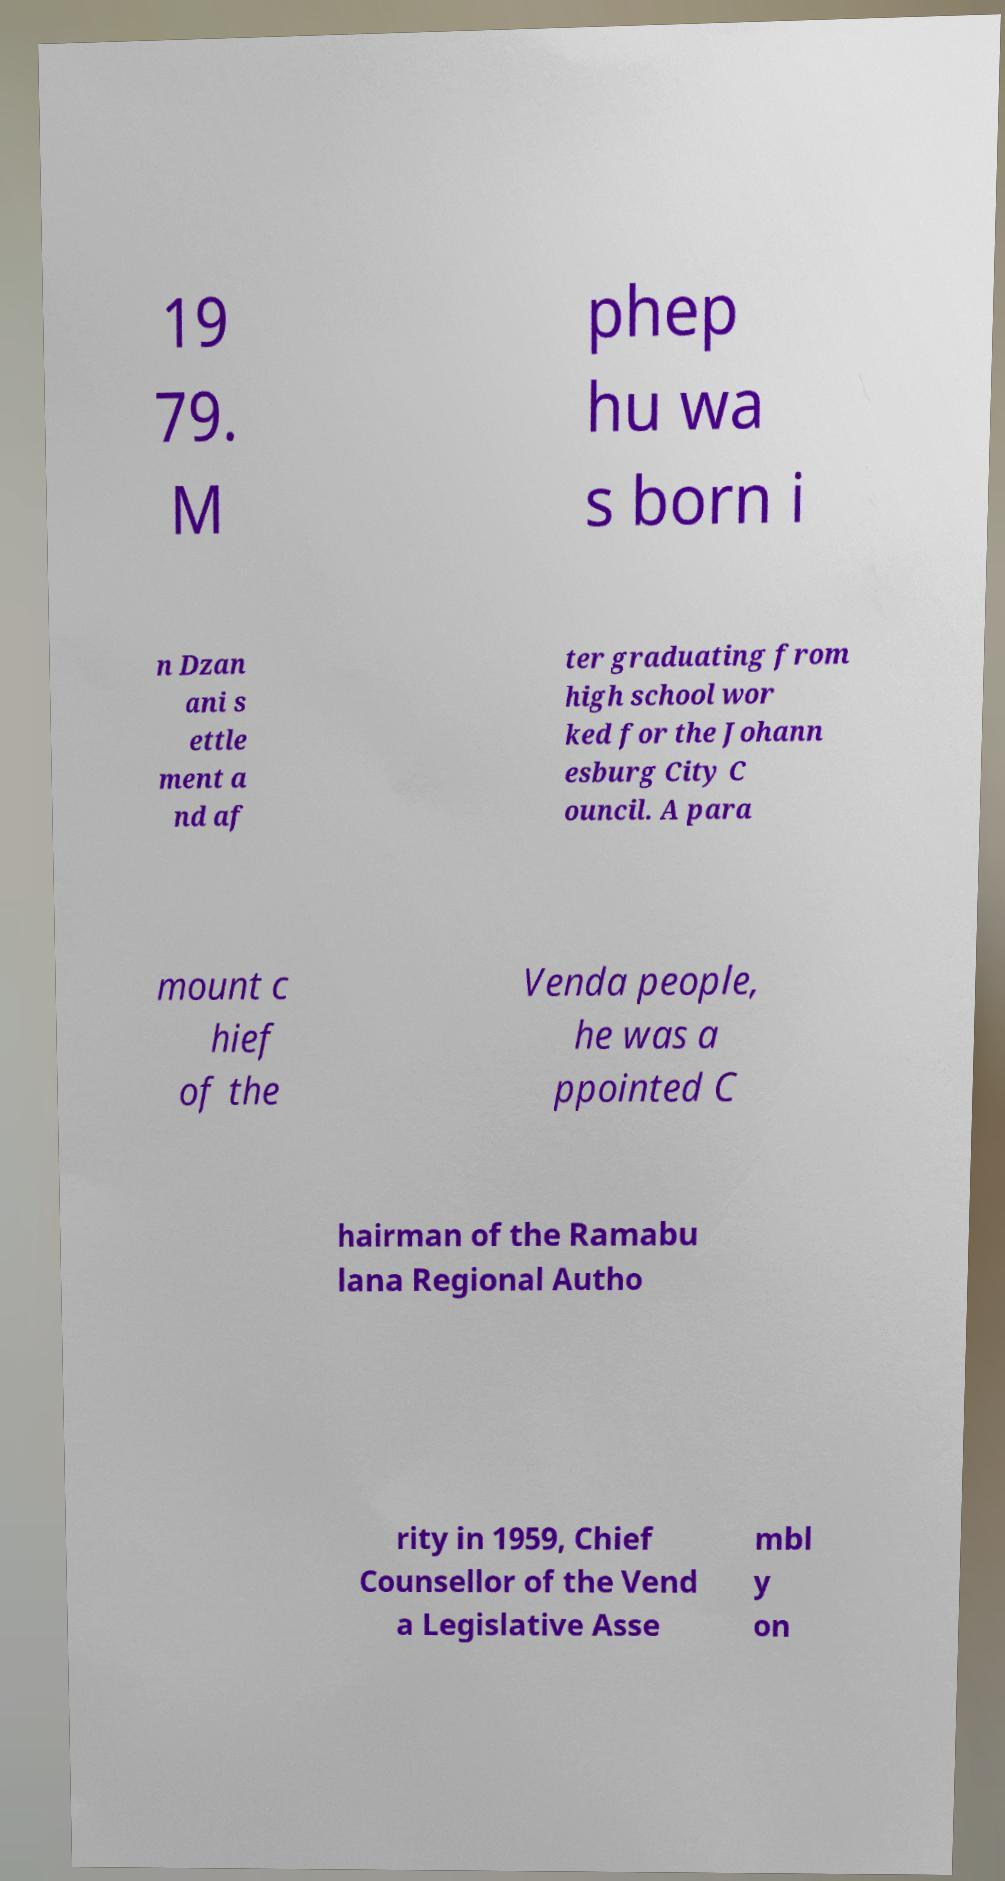Could you assist in decoding the text presented in this image and type it out clearly? 19 79. M phep hu wa s born i n Dzan ani s ettle ment a nd af ter graduating from high school wor ked for the Johann esburg City C ouncil. A para mount c hief of the Venda people, he was a ppointed C hairman of the Ramabu lana Regional Autho rity in 1959, Chief Counsellor of the Vend a Legislative Asse mbl y on 